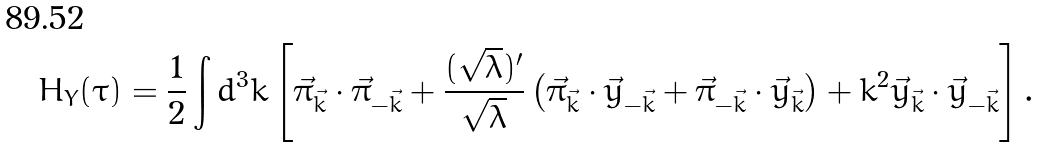Convert formula to latex. <formula><loc_0><loc_0><loc_500><loc_500>H _ { Y } ( \tau ) = \frac { 1 } { 2 } \int d ^ { 3 } k \left [ \vec { \pi } _ { \vec { k } } \cdot \vec { \pi } _ { - \vec { k } } + \frac { ( \sqrt { \lambda } ) ^ { \prime } } { \sqrt { \lambda } } \left ( \vec { \pi } _ { \vec { k } } \cdot \vec { y } _ { - \vec { k } } + \vec { \pi } _ { - \vec { k } } \cdot \vec { y } _ { \vec { k } } \right ) + k ^ { 2 } \vec { y } _ { \vec { k } } \cdot \vec { y } _ { - \vec { k } } \right ] .</formula> 